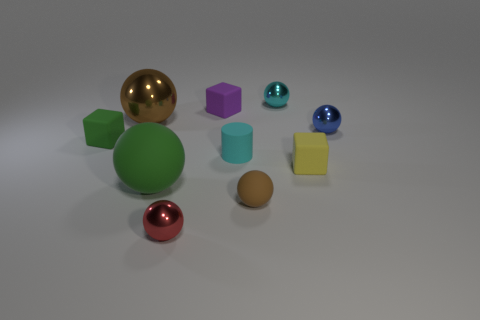Subtract all tiny cyan metal balls. How many balls are left? 5 Subtract all brown spheres. How many spheres are left? 4 Subtract all gray spheres. Subtract all brown cubes. How many spheres are left? 6 Subtract all cubes. How many objects are left? 7 Add 9 cyan metallic things. How many cyan metallic things are left? 10 Add 8 cyan rubber cylinders. How many cyan rubber cylinders exist? 9 Subtract 0 gray spheres. How many objects are left? 10 Subtract all red rubber cylinders. Subtract all large shiny balls. How many objects are left? 9 